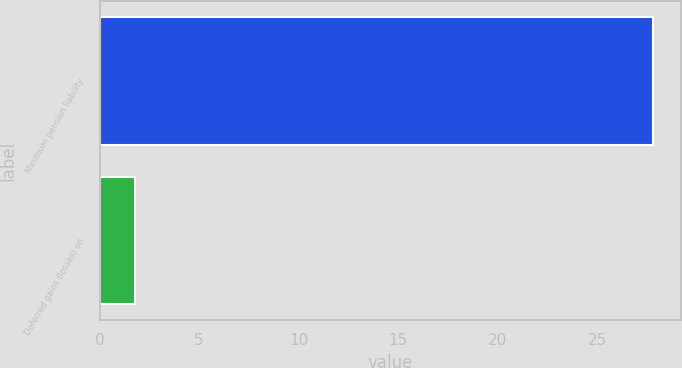Convert chart to OTSL. <chart><loc_0><loc_0><loc_500><loc_500><bar_chart><fcel>Minimum pension liability<fcel>Deferred gains (losses) on<nl><fcel>27.8<fcel>1.8<nl></chart> 